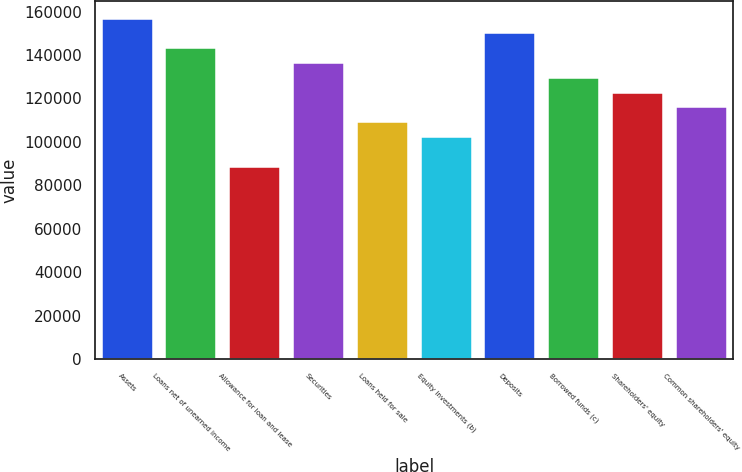Convert chart to OTSL. <chart><loc_0><loc_0><loc_500><loc_500><bar_chart><fcel>Assets<fcel>Loans net of unearned income<fcel>Allowance for loan and lease<fcel>Securities<fcel>Loans held for sale<fcel>Equity investments (b)<fcel>Deposits<fcel>Borrowed funds (c)<fcel>Shareholders' equity<fcel>Common shareholders' equity<nl><fcel>156784<fcel>143151<fcel>88617.9<fcel>136334<fcel>109068<fcel>102251<fcel>149968<fcel>129518<fcel>122701<fcel>115885<nl></chart> 